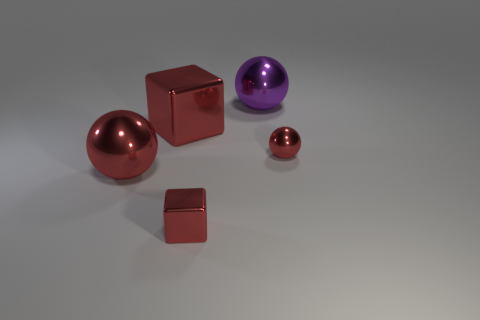Can you describe the arrangement and colors of the objects in this image? Certainly! The image features a collection of geometric shapes arranged on a neutral surface. Closest to us is a small metallic sphere with a shiny finish, reflecting the environment. Just beyond it is a small metallic cube with a red reflective surface, and behind it sits one small metallic ball. Further away is a large, shiny red sphere that draws the eye due to its size and vibrant color. The use of metallic textures across the objects adds a uniformity to the variety of shapes and sizes. 